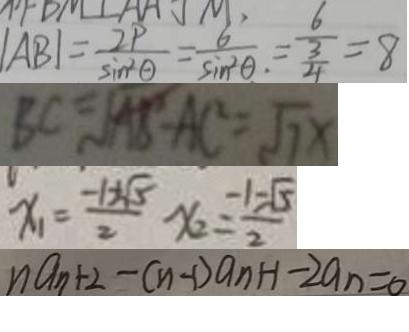<formula> <loc_0><loc_0><loc_500><loc_500>\vert A B \vert = \frac { 2 P } { \sin ^ { 2 } \theta } = \frac { 6 } { \sin ^ { 2 } \theta . } = \frac { 6 } { \frac { 3 } { 4 } } = 8 
 B C = \sqrt { A B ^ { 2 } - A C ^ { 2 } } = \sqrt { 7 } x 
 x _ { 1 } = \frac { - 1 + \sqrt { 5 } } { 2 } x _ { 2 } = \frac { - 1 - \sqrt { 5 } } { 2 } 
 n a _ { n + 2 } - ( n - 1 ) a _ { n } + 1 - 2 a _ { n } = 0</formula> 